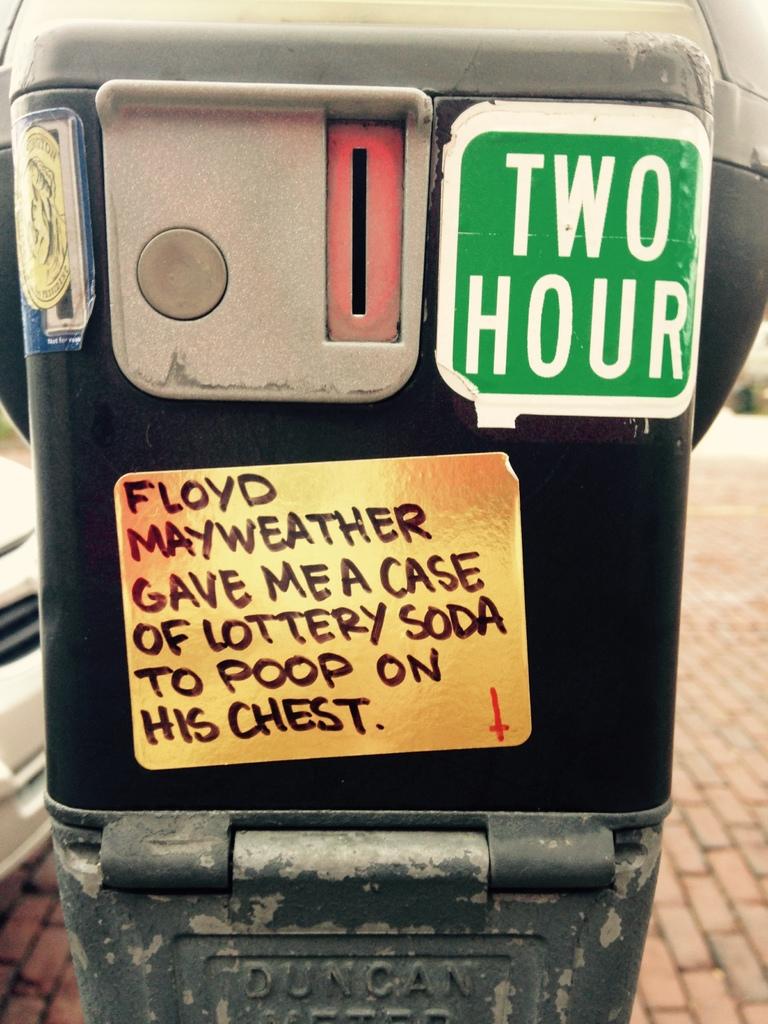What is about?
Make the answer very short. Unanswerable. Did floyd mayweather really do this?!?
Provide a succinct answer. Unanswerable. 